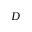<formula> <loc_0><loc_0><loc_500><loc_500>D</formula> 